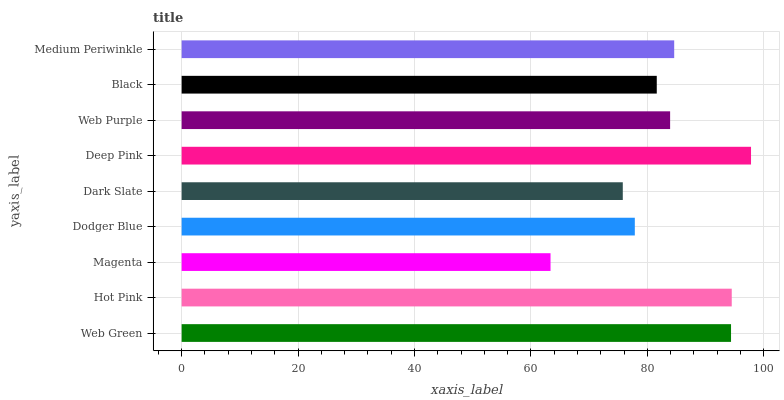Is Magenta the minimum?
Answer yes or no. Yes. Is Deep Pink the maximum?
Answer yes or no. Yes. Is Hot Pink the minimum?
Answer yes or no. No. Is Hot Pink the maximum?
Answer yes or no. No. Is Hot Pink greater than Web Green?
Answer yes or no. Yes. Is Web Green less than Hot Pink?
Answer yes or no. Yes. Is Web Green greater than Hot Pink?
Answer yes or no. No. Is Hot Pink less than Web Green?
Answer yes or no. No. Is Web Purple the high median?
Answer yes or no. Yes. Is Web Purple the low median?
Answer yes or no. Yes. Is Medium Periwinkle the high median?
Answer yes or no. No. Is Medium Periwinkle the low median?
Answer yes or no. No. 